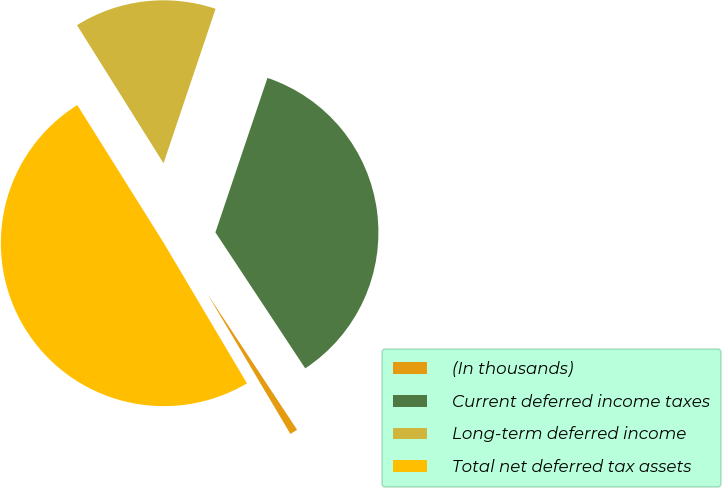Convert chart. <chart><loc_0><loc_0><loc_500><loc_500><pie_chart><fcel>(In thousands)<fcel>Current deferred income taxes<fcel>Long-term deferred income<fcel>Total net deferred tax assets<nl><fcel>0.77%<fcel>35.54%<fcel>14.08%<fcel>49.61%<nl></chart> 